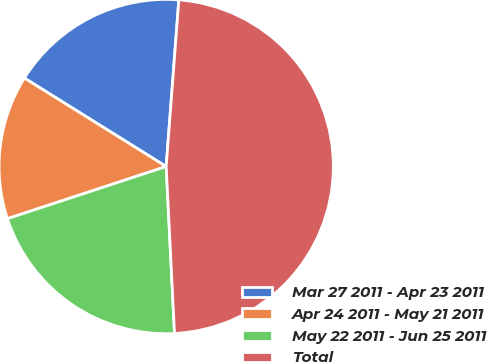Convert chart to OTSL. <chart><loc_0><loc_0><loc_500><loc_500><pie_chart><fcel>Mar 27 2011 - Apr 23 2011<fcel>Apr 24 2011 - May 21 2011<fcel>May 22 2011 - Jun 25 2011<fcel>Total<nl><fcel>17.33%<fcel>13.93%<fcel>20.74%<fcel>48.0%<nl></chart> 